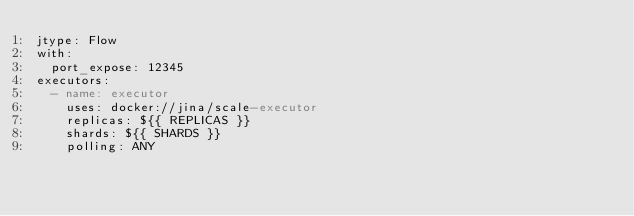Convert code to text. <code><loc_0><loc_0><loc_500><loc_500><_YAML_>jtype: Flow
with:
  port_expose: 12345
executors:
  - name: executor
    uses: docker://jina/scale-executor
    replicas: ${{ REPLICAS }}
    shards: ${{ SHARDS }}
    polling: ANY
</code> 